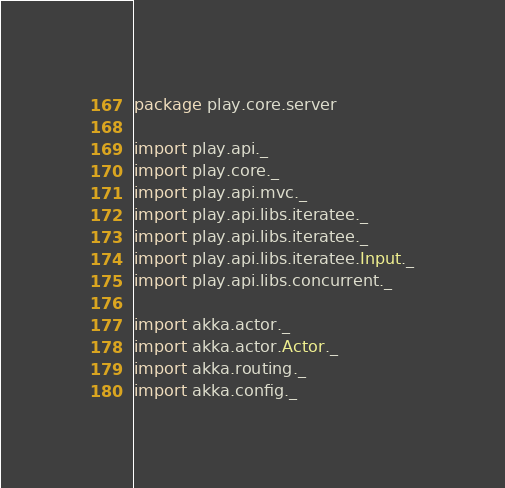Convert code to text. <code><loc_0><loc_0><loc_500><loc_500><_Scala_>package play.core.server

import play.api._
import play.core._
import play.api.mvc._
import play.api.libs.iteratee._
import play.api.libs.iteratee._
import play.api.libs.iteratee.Input._
import play.api.libs.concurrent._

import akka.actor._
import akka.actor.Actor._
import akka.routing._
import akka.config._</code> 